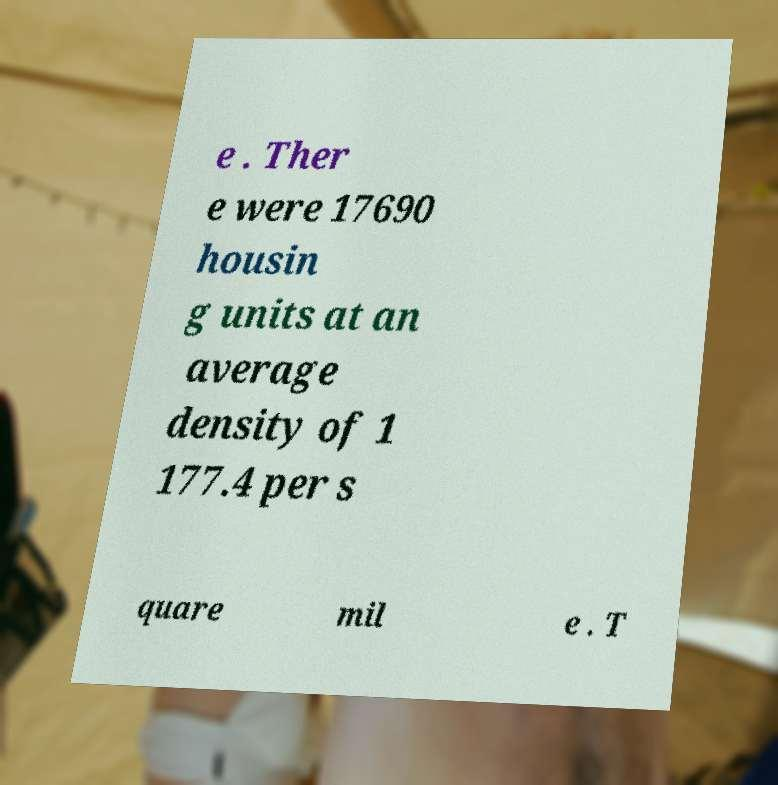What messages or text are displayed in this image? I need them in a readable, typed format. e . Ther e were 17690 housin g units at an average density of 1 177.4 per s quare mil e . T 